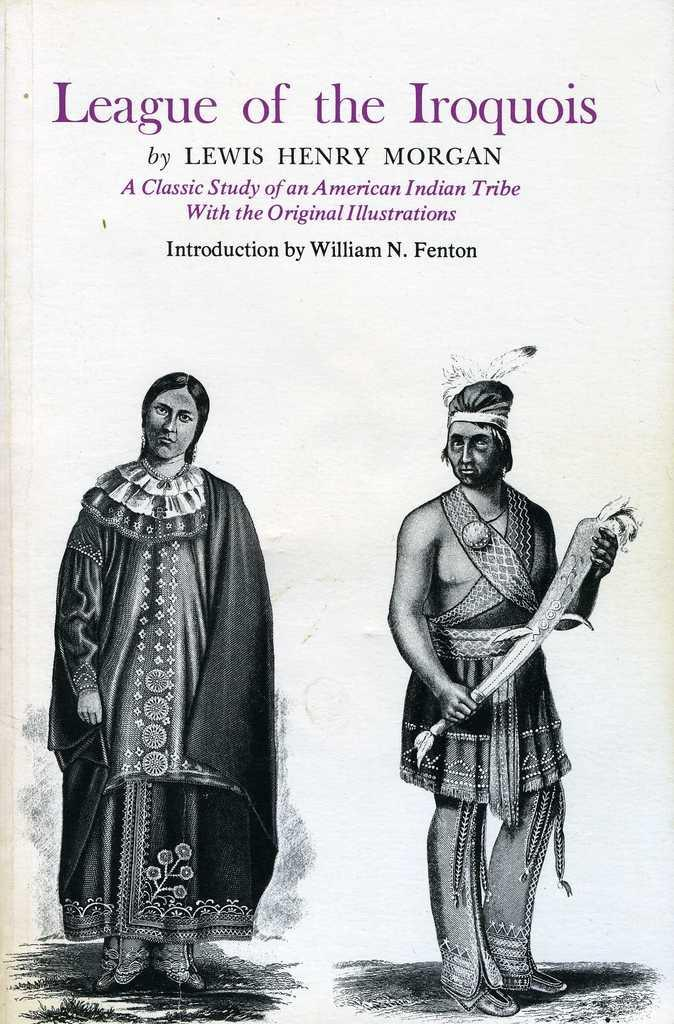What type of image is being described? The image is a cover page of a book. How many people are depicted on the cover? There are two persons in the image. Is there any text present on the cover page? Yes, there is text visible at the top of the image. What color is the surprise in the image? There is no surprise present in the image, as it is a book cover with two persons and text. 